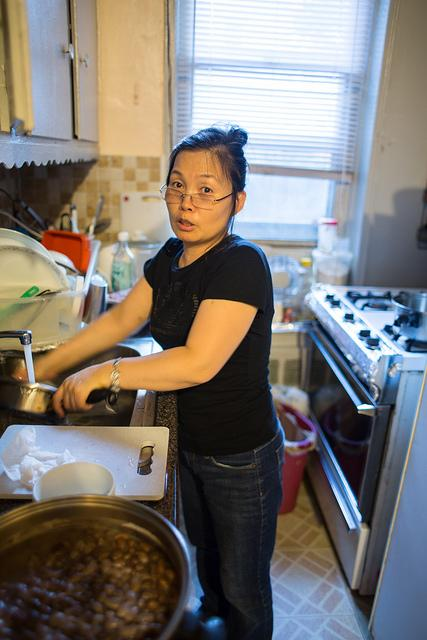What chore does the woman perform? Please explain your reasoning. dish washing. She is using the sink to clean a pot. 